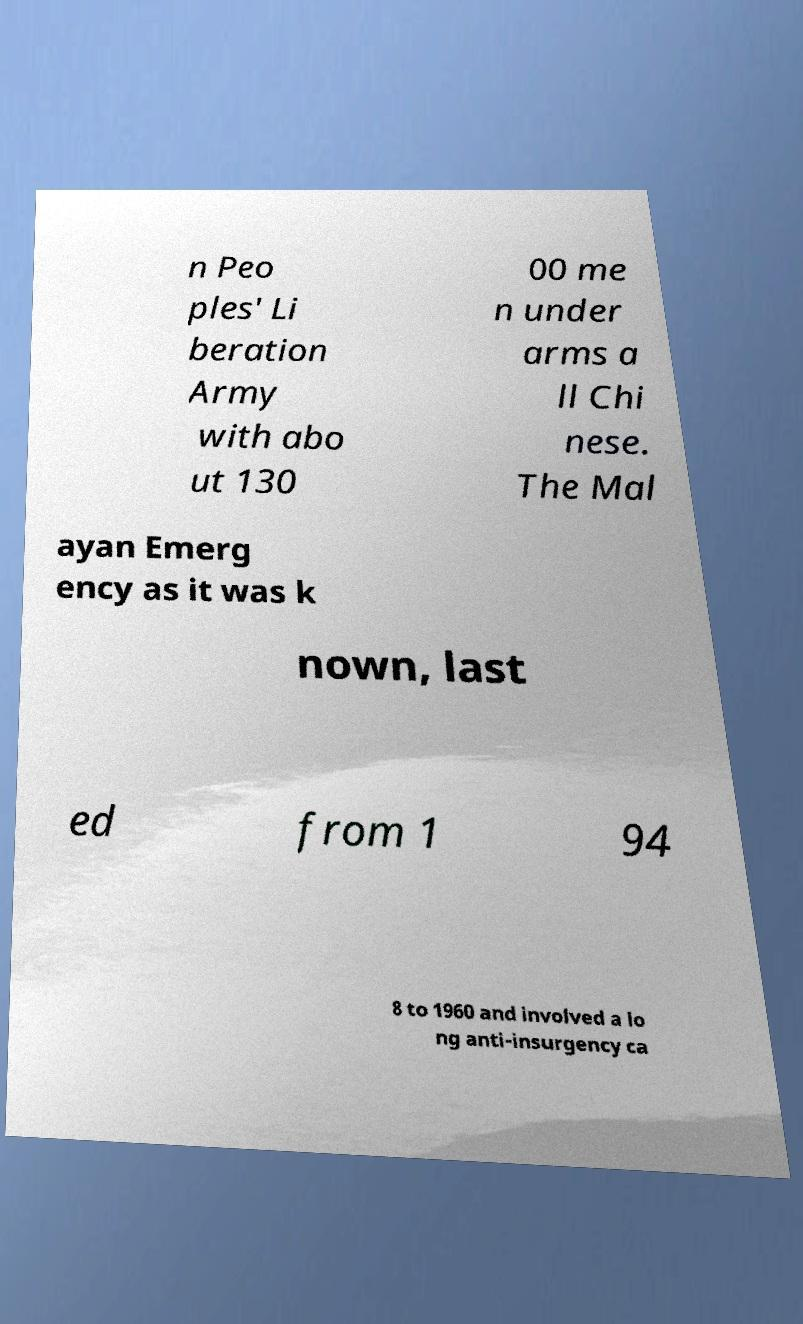Please identify and transcribe the text found in this image. n Peo ples' Li beration Army with abo ut 130 00 me n under arms a ll Chi nese. The Mal ayan Emerg ency as it was k nown, last ed from 1 94 8 to 1960 and involved a lo ng anti-insurgency ca 